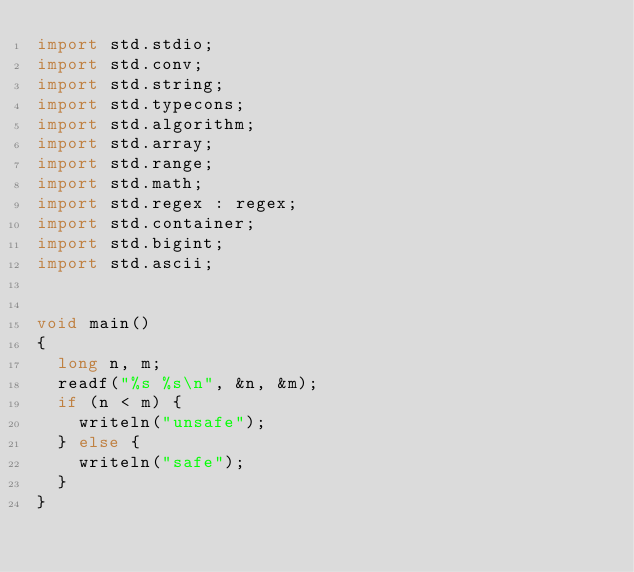<code> <loc_0><loc_0><loc_500><loc_500><_D_>import std.stdio;
import std.conv;
import std.string;
import std.typecons;
import std.algorithm;
import std.array;
import std.range;
import std.math;
import std.regex : regex;
import std.container;
import std.bigint;
import std.ascii;


void main()
{
  long n, m;
  readf("%s %s\n", &n, &m);
  if (n < m) {
    writeln("unsafe");
  } else {
    writeln("safe");
  }
}
</code> 